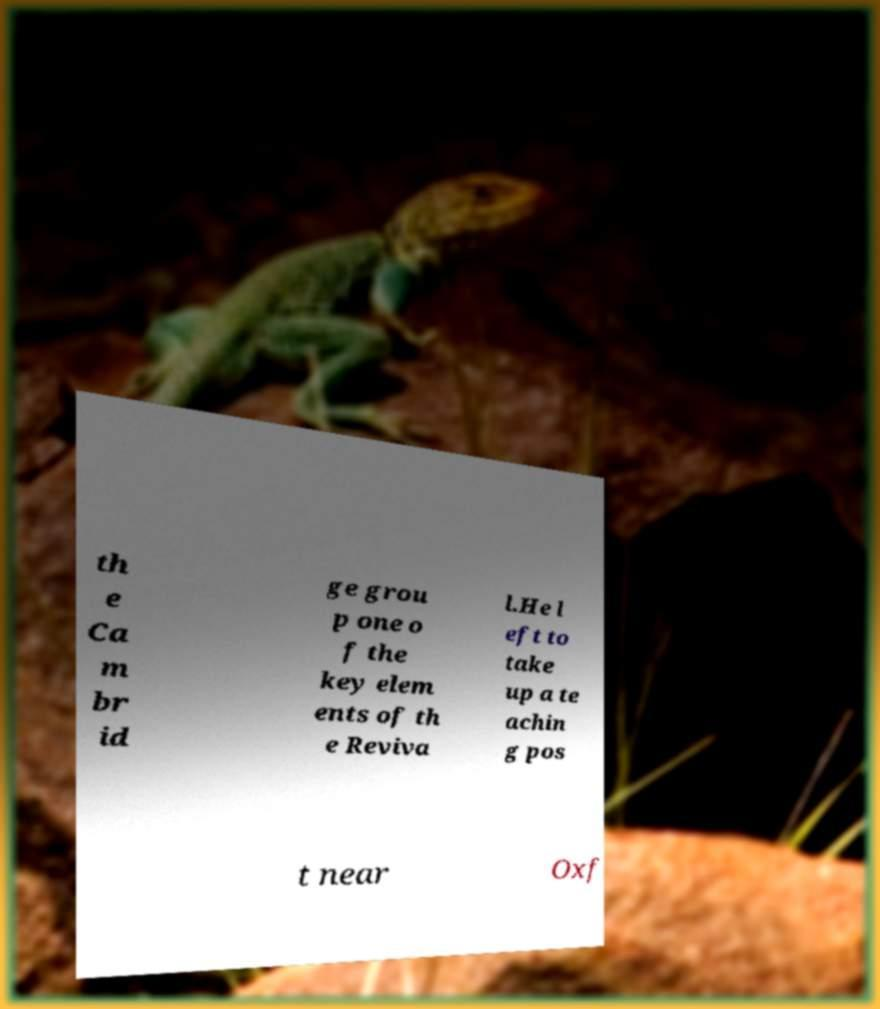There's text embedded in this image that I need extracted. Can you transcribe it verbatim? th e Ca m br id ge grou p one o f the key elem ents of th e Reviva l.He l eft to take up a te achin g pos t near Oxf 